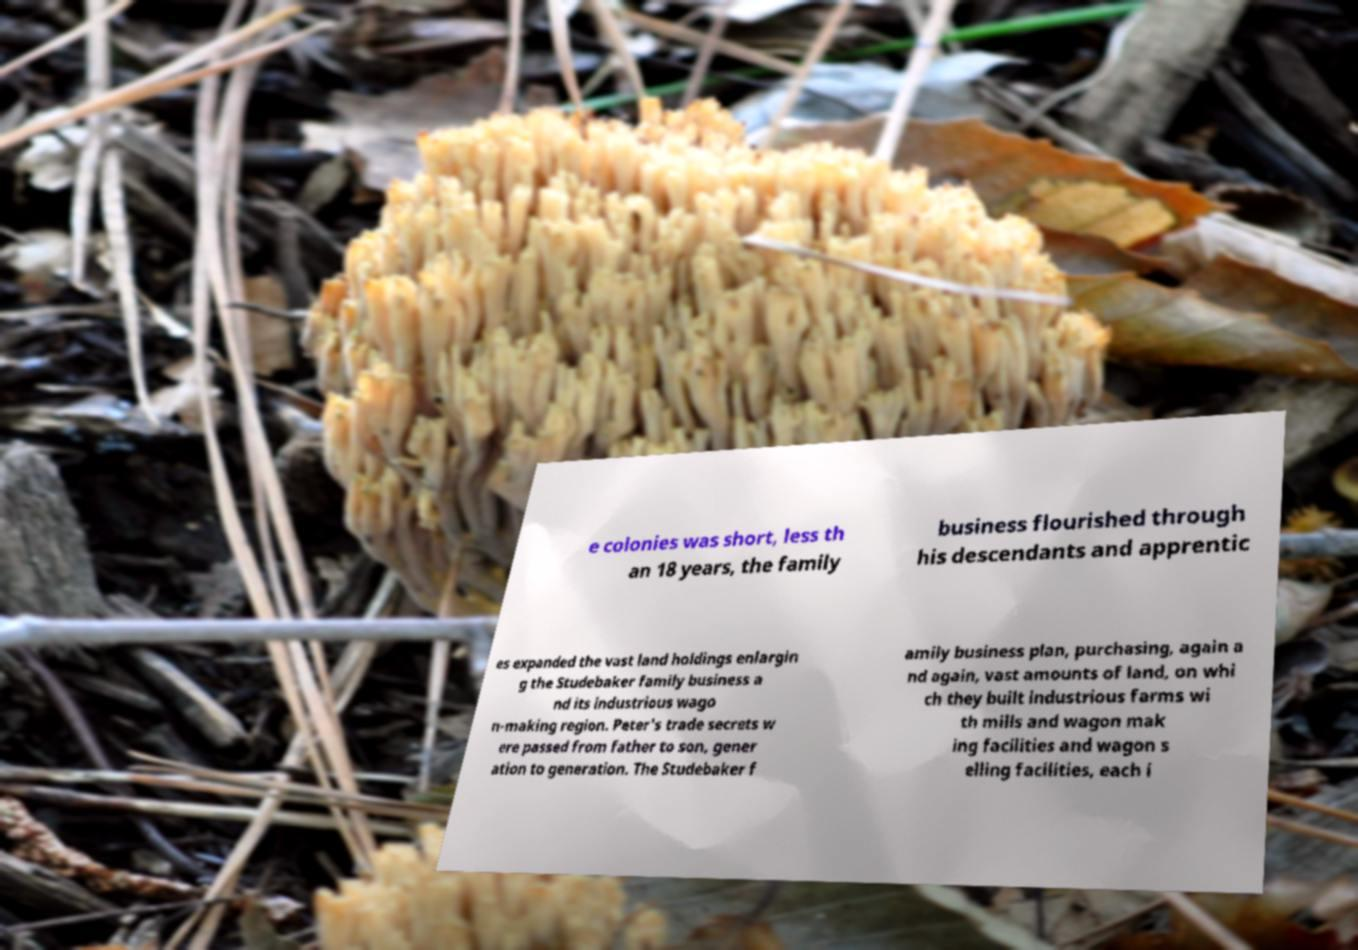What messages or text are displayed in this image? I need them in a readable, typed format. e colonies was short, less th an 18 years, the family business flourished through his descendants and apprentic es expanded the vast land holdings enlargin g the Studebaker family business a nd its industrious wago n-making region. Peter's trade secrets w ere passed from father to son, gener ation to generation. The Studebaker f amily business plan, purchasing, again a nd again, vast amounts of land, on whi ch they built industrious farms wi th mills and wagon mak ing facilities and wagon s elling facilities, each i 